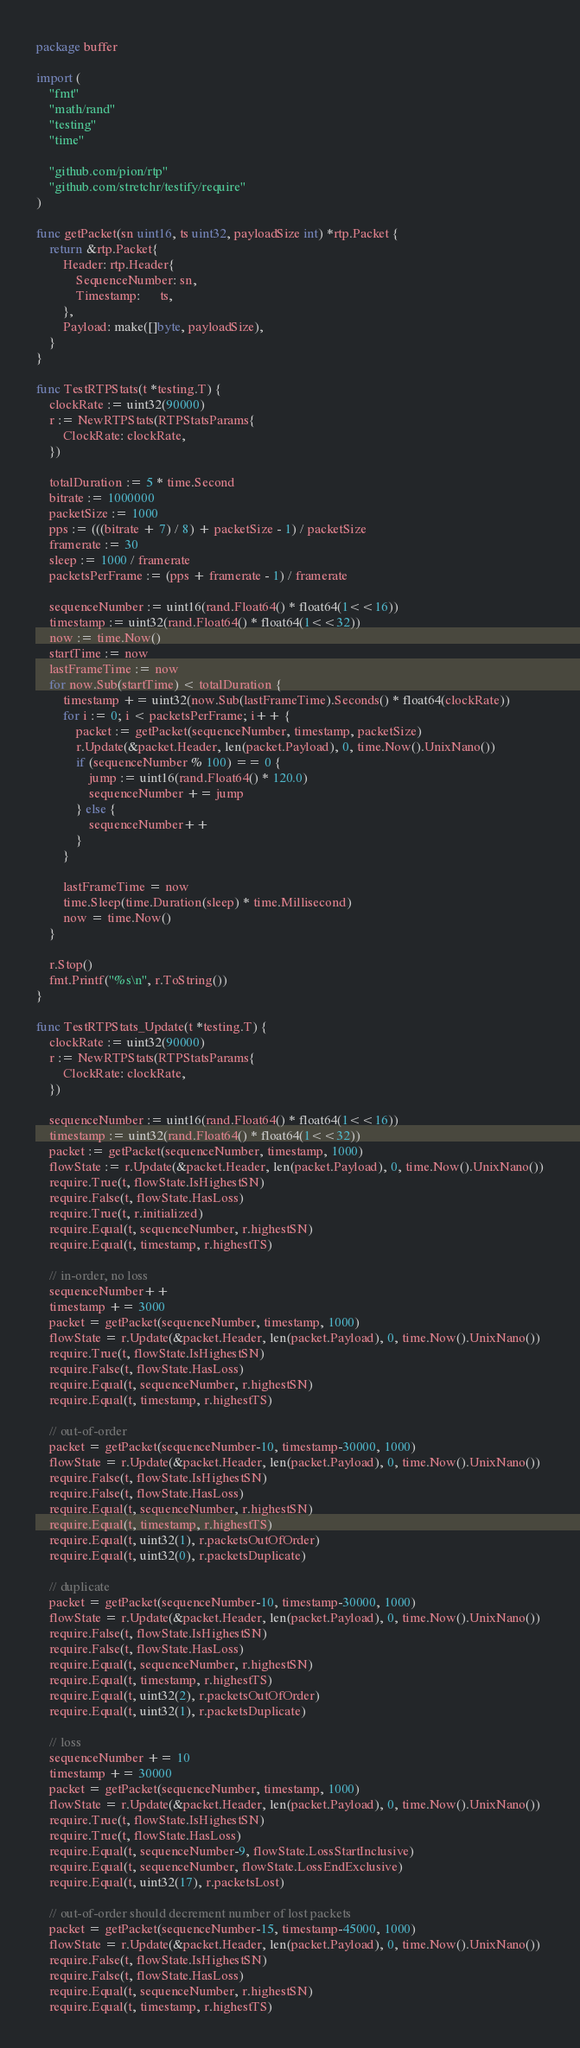<code> <loc_0><loc_0><loc_500><loc_500><_Go_>package buffer

import (
	"fmt"
	"math/rand"
	"testing"
	"time"

	"github.com/pion/rtp"
	"github.com/stretchr/testify/require"
)

func getPacket(sn uint16, ts uint32, payloadSize int) *rtp.Packet {
	return &rtp.Packet{
		Header: rtp.Header{
			SequenceNumber: sn,
			Timestamp:      ts,
		},
		Payload: make([]byte, payloadSize),
	}
}

func TestRTPStats(t *testing.T) {
	clockRate := uint32(90000)
	r := NewRTPStats(RTPStatsParams{
		ClockRate: clockRate,
	})

	totalDuration := 5 * time.Second
	bitrate := 1000000
	packetSize := 1000
	pps := (((bitrate + 7) / 8) + packetSize - 1) / packetSize
	framerate := 30
	sleep := 1000 / framerate
	packetsPerFrame := (pps + framerate - 1) / framerate

	sequenceNumber := uint16(rand.Float64() * float64(1<<16))
	timestamp := uint32(rand.Float64() * float64(1<<32))
	now := time.Now()
	startTime := now
	lastFrameTime := now
	for now.Sub(startTime) < totalDuration {
		timestamp += uint32(now.Sub(lastFrameTime).Seconds() * float64(clockRate))
		for i := 0; i < packetsPerFrame; i++ {
			packet := getPacket(sequenceNumber, timestamp, packetSize)
			r.Update(&packet.Header, len(packet.Payload), 0, time.Now().UnixNano())
			if (sequenceNumber % 100) == 0 {
				jump := uint16(rand.Float64() * 120.0)
				sequenceNumber += jump
			} else {
				sequenceNumber++
			}
		}

		lastFrameTime = now
		time.Sleep(time.Duration(sleep) * time.Millisecond)
		now = time.Now()
	}

	r.Stop()
	fmt.Printf("%s\n", r.ToString())
}

func TestRTPStats_Update(t *testing.T) {
	clockRate := uint32(90000)
	r := NewRTPStats(RTPStatsParams{
		ClockRate: clockRate,
	})

	sequenceNumber := uint16(rand.Float64() * float64(1<<16))
	timestamp := uint32(rand.Float64() * float64(1<<32))
	packet := getPacket(sequenceNumber, timestamp, 1000)
	flowState := r.Update(&packet.Header, len(packet.Payload), 0, time.Now().UnixNano())
	require.True(t, flowState.IsHighestSN)
	require.False(t, flowState.HasLoss)
	require.True(t, r.initialized)
	require.Equal(t, sequenceNumber, r.highestSN)
	require.Equal(t, timestamp, r.highestTS)

	// in-order, no loss
	sequenceNumber++
	timestamp += 3000
	packet = getPacket(sequenceNumber, timestamp, 1000)
	flowState = r.Update(&packet.Header, len(packet.Payload), 0, time.Now().UnixNano())
	require.True(t, flowState.IsHighestSN)
	require.False(t, flowState.HasLoss)
	require.Equal(t, sequenceNumber, r.highestSN)
	require.Equal(t, timestamp, r.highestTS)

	// out-of-order
	packet = getPacket(sequenceNumber-10, timestamp-30000, 1000)
	flowState = r.Update(&packet.Header, len(packet.Payload), 0, time.Now().UnixNano())
	require.False(t, flowState.IsHighestSN)
	require.False(t, flowState.HasLoss)
	require.Equal(t, sequenceNumber, r.highestSN)
	require.Equal(t, timestamp, r.highestTS)
	require.Equal(t, uint32(1), r.packetsOutOfOrder)
	require.Equal(t, uint32(0), r.packetsDuplicate)

	// duplicate
	packet = getPacket(sequenceNumber-10, timestamp-30000, 1000)
	flowState = r.Update(&packet.Header, len(packet.Payload), 0, time.Now().UnixNano())
	require.False(t, flowState.IsHighestSN)
	require.False(t, flowState.HasLoss)
	require.Equal(t, sequenceNumber, r.highestSN)
	require.Equal(t, timestamp, r.highestTS)
	require.Equal(t, uint32(2), r.packetsOutOfOrder)
	require.Equal(t, uint32(1), r.packetsDuplicate)

	// loss
	sequenceNumber += 10
	timestamp += 30000
	packet = getPacket(sequenceNumber, timestamp, 1000)
	flowState = r.Update(&packet.Header, len(packet.Payload), 0, time.Now().UnixNano())
	require.True(t, flowState.IsHighestSN)
	require.True(t, flowState.HasLoss)
	require.Equal(t, sequenceNumber-9, flowState.LossStartInclusive)
	require.Equal(t, sequenceNumber, flowState.LossEndExclusive)
	require.Equal(t, uint32(17), r.packetsLost)

	// out-of-order should decrement number of lost packets
	packet = getPacket(sequenceNumber-15, timestamp-45000, 1000)
	flowState = r.Update(&packet.Header, len(packet.Payload), 0, time.Now().UnixNano())
	require.False(t, flowState.IsHighestSN)
	require.False(t, flowState.HasLoss)
	require.Equal(t, sequenceNumber, r.highestSN)
	require.Equal(t, timestamp, r.highestTS)</code> 